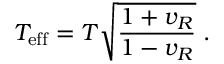<formula> <loc_0><loc_0><loc_500><loc_500>T _ { e f f } = T \sqrt { \frac { 1 + v _ { R } } { 1 - v _ { R } } } \, .</formula> 